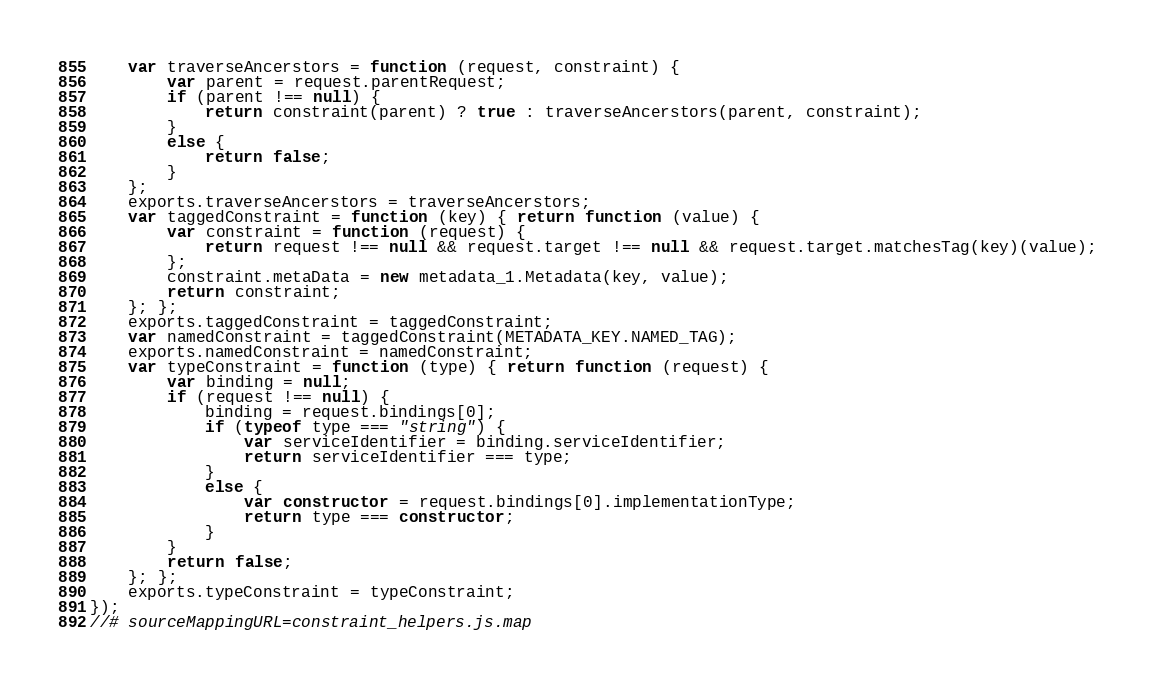<code> <loc_0><loc_0><loc_500><loc_500><_JavaScript_>    var traverseAncerstors = function (request, constraint) {
        var parent = request.parentRequest;
        if (parent !== null) {
            return constraint(parent) ? true : traverseAncerstors(parent, constraint);
        }
        else {
            return false;
        }
    };
    exports.traverseAncerstors = traverseAncerstors;
    var taggedConstraint = function (key) { return function (value) {
        var constraint = function (request) {
            return request !== null && request.target !== null && request.target.matchesTag(key)(value);
        };
        constraint.metaData = new metadata_1.Metadata(key, value);
        return constraint;
    }; };
    exports.taggedConstraint = taggedConstraint;
    var namedConstraint = taggedConstraint(METADATA_KEY.NAMED_TAG);
    exports.namedConstraint = namedConstraint;
    var typeConstraint = function (type) { return function (request) {
        var binding = null;
        if (request !== null) {
            binding = request.bindings[0];
            if (typeof type === "string") {
                var serviceIdentifier = binding.serviceIdentifier;
                return serviceIdentifier === type;
            }
            else {
                var constructor = request.bindings[0].implementationType;
                return type === constructor;
            }
        }
        return false;
    }; };
    exports.typeConstraint = typeConstraint;
});
//# sourceMappingURL=constraint_helpers.js.map</code> 